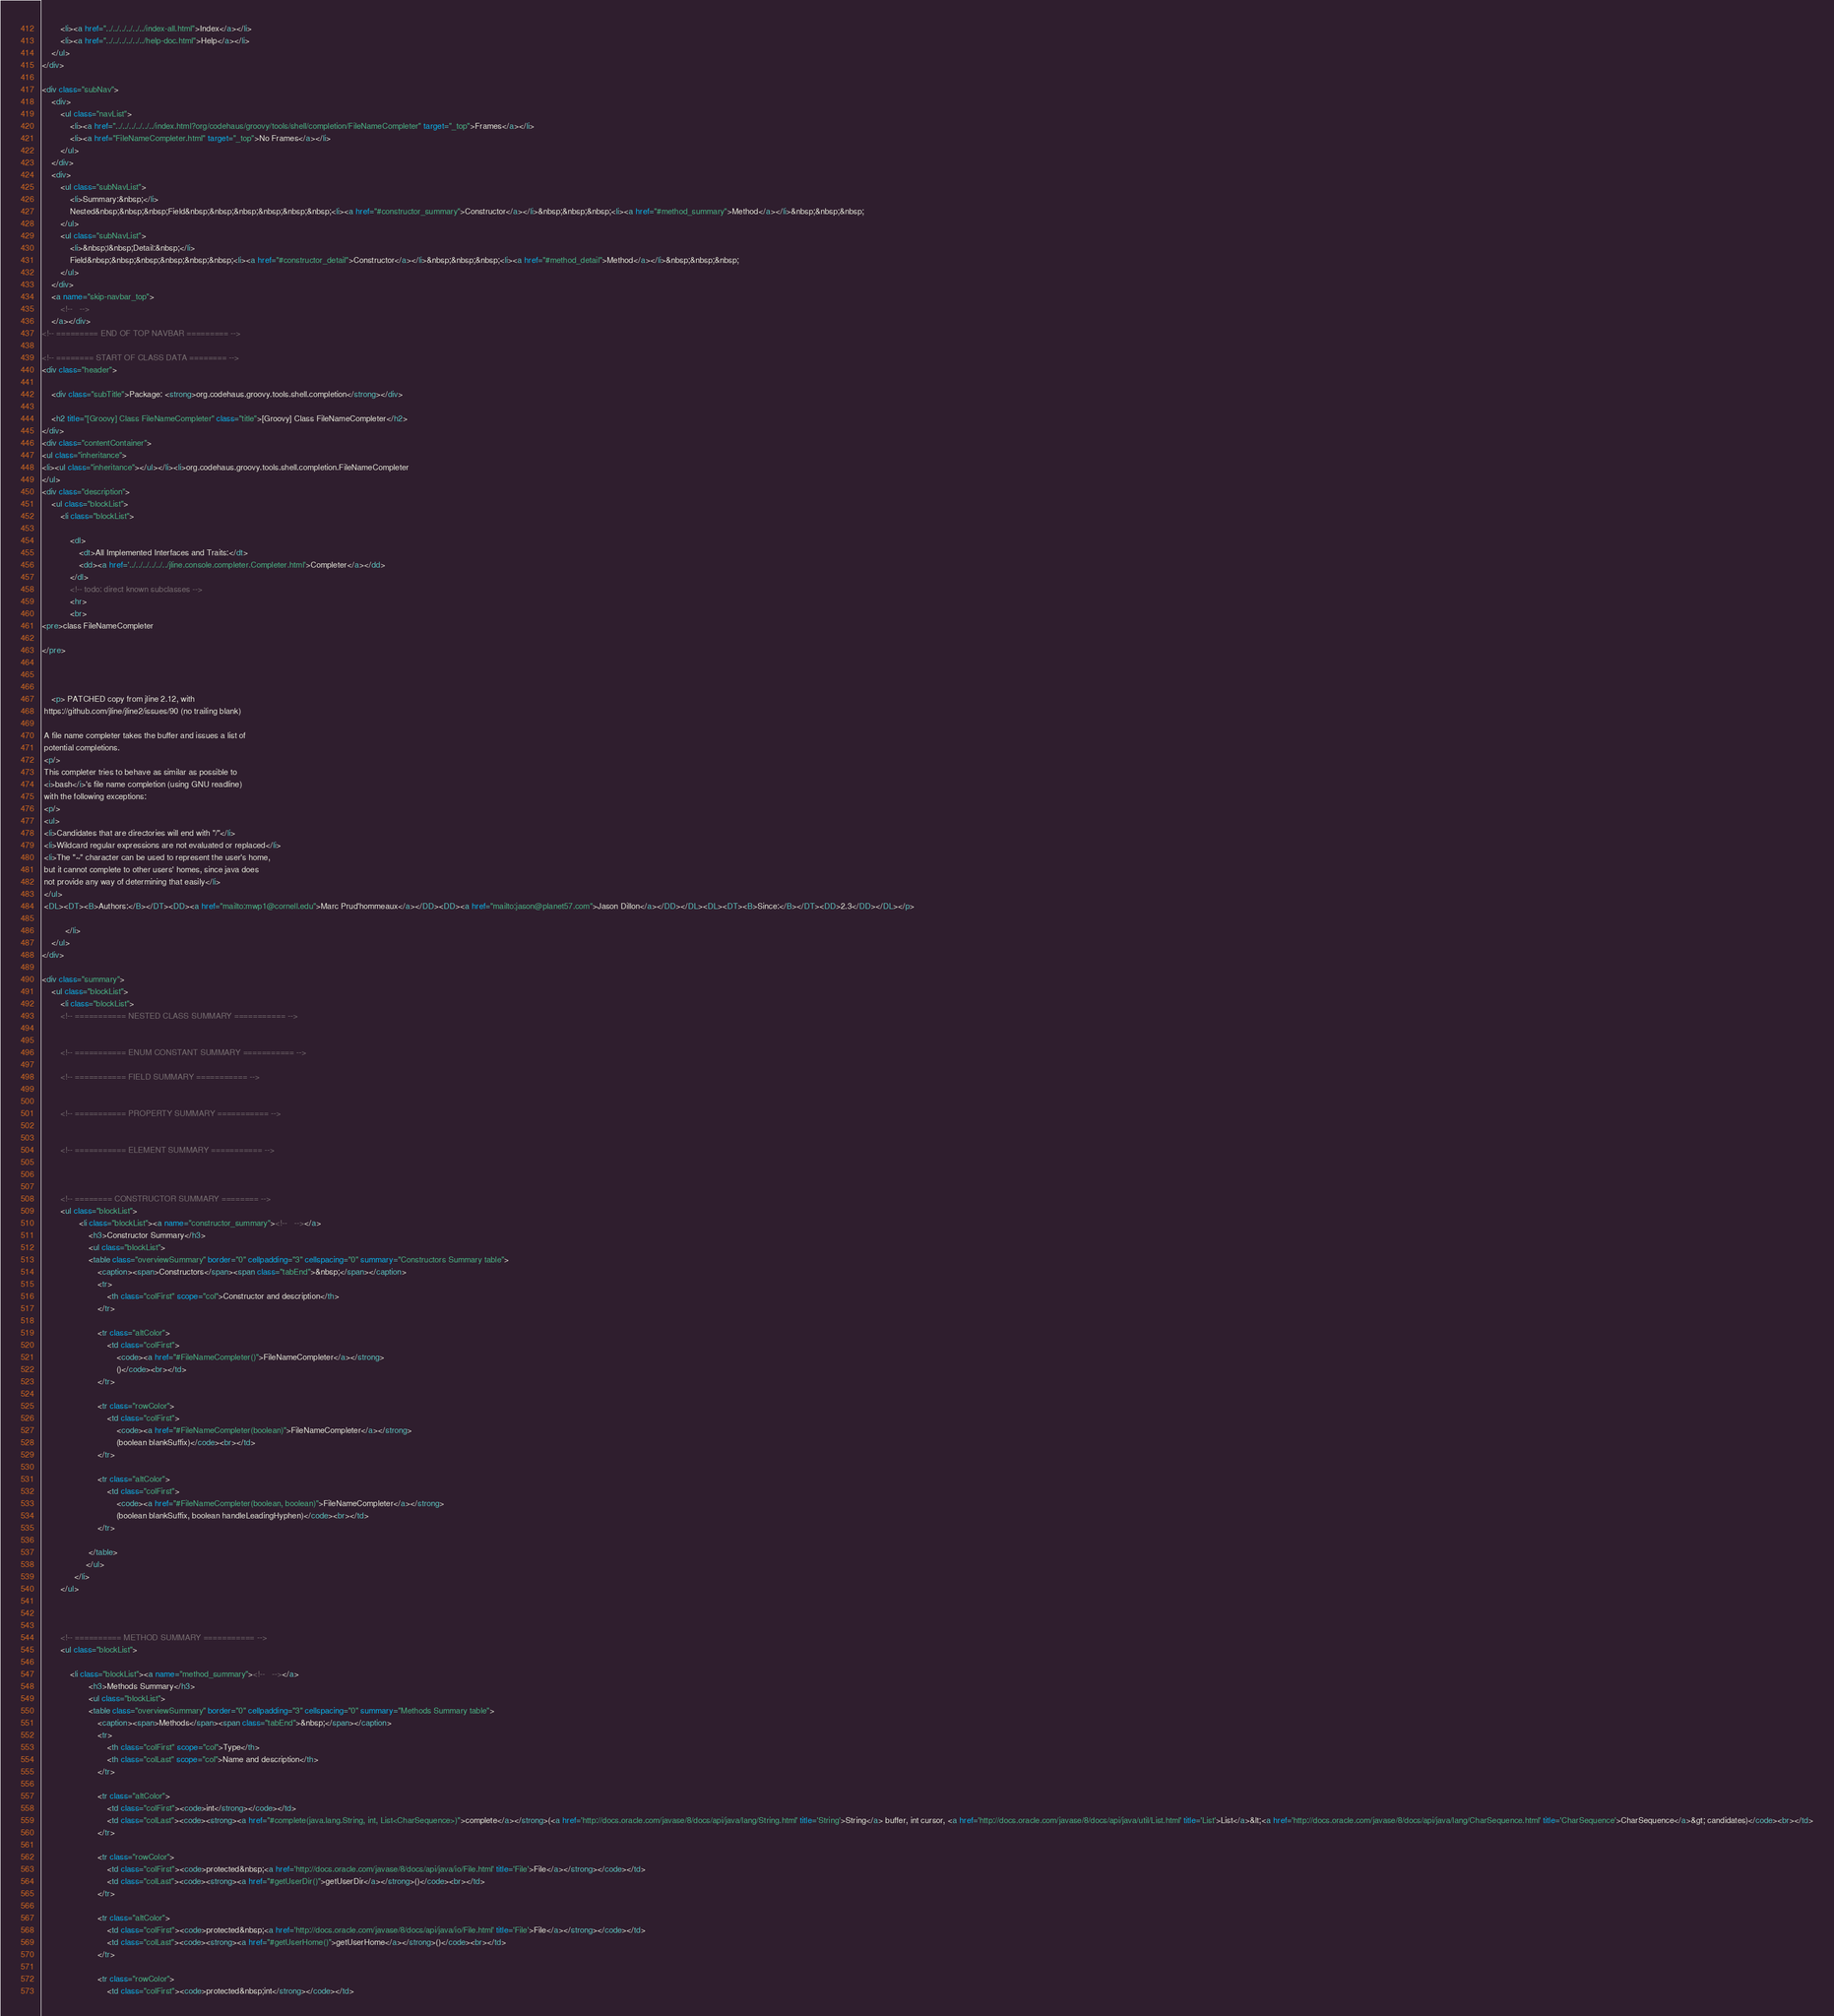Convert code to text. <code><loc_0><loc_0><loc_500><loc_500><_HTML_>        <li><a href="../../../../../../index-all.html">Index</a></li>
        <li><a href="../../../../../../help-doc.html">Help</a></li>
    </ul>
</div>

<div class="subNav">
    <div>
        <ul class="navList">
            <li><a href="../../../../../../index.html?org/codehaus/groovy/tools/shell/completion/FileNameCompleter" target="_top">Frames</a></li>
            <li><a href="FileNameCompleter.html" target="_top">No Frames</a></li>
        </ul>
    </div>
    <div>
        <ul class="subNavList">
            <li>Summary:&nbsp;</li>
            Nested&nbsp;&nbsp;&nbsp;Field&nbsp;&nbsp;&nbsp;&nbsp;&nbsp;&nbsp;<li><a href="#constructor_summary">Constructor</a></li>&nbsp;&nbsp;&nbsp;<li><a href="#method_summary">Method</a></li>&nbsp;&nbsp;&nbsp;
        </ul>
        <ul class="subNavList">
            <li>&nbsp;|&nbsp;Detail:&nbsp;</li>
            Field&nbsp;&nbsp;&nbsp;&nbsp;&nbsp;&nbsp;<li><a href="#constructor_detail">Constructor</a></li>&nbsp;&nbsp;&nbsp;<li><a href="#method_detail">Method</a></li>&nbsp;&nbsp;&nbsp;
        </ul>
    </div>
    <a name="skip-navbar_top">
        <!--   -->
    </a></div>
<!-- ========= END OF TOP NAVBAR ========= -->

<!-- ======== START OF CLASS DATA ======== -->
<div class="header">

    <div class="subTitle">Package: <strong>org.codehaus.groovy.tools.shell.completion</strong></div>

    <h2 title="[Groovy] Class FileNameCompleter" class="title">[Groovy] Class FileNameCompleter</h2>
</div>
<div class="contentContainer">
<ul class="inheritance">
<li><ul class="inheritance"></ul></li><li>org.codehaus.groovy.tools.shell.completion.FileNameCompleter
</ul>
<div class="description">
    <ul class="blockList">
        <li class="blockList">

            <dl>
                <dt>All Implemented Interfaces and Traits:</dt>
                <dd><a href='../../../../../../jline.console.completer.Completer.html'>Completer</a></dd>
            </dl>
            <!-- todo: direct known subclasses -->
            <hr>
            <br>
<pre>class FileNameCompleter

</pre>



    <p> PATCHED copy from jline 2.12, with
 https://github.com/jline/jline2/issues/90 (no trailing blank)

 A file name completer takes the buffer and issues a list of
 potential completions.
 <p/>
 This completer tries to behave as similar as possible to
 <i>bash</i>'s file name completion (using GNU readline)
 with the following exceptions:
 <p/>
 <ul>
 <li>Candidates that are directories will end with "/"</li>
 <li>Wildcard regular expressions are not evaluated or replaced</li>
 <li>The "~" character can be used to represent the user's home,
 but it cannot complete to other users' homes, since java does
 not provide any way of determining that easily</li>
 </ul>
 <DL><DT><B>Authors:</B></DT><DD><a href="mailto:mwp1@cornell.edu">Marc Prud'hommeaux</a></DD><DD><a href="mailto:jason@planet57.com">Jason Dillon</a></DD></DL><DL><DT><B>Since:</B></DT><DD>2.3</DD></DL></p>

          </li>
    </ul>
</div>

<div class="summary">
    <ul class="blockList">
        <li class="blockList">
        <!-- =========== NESTED CLASS SUMMARY =========== -->
        

        <!-- =========== ENUM CONSTANT SUMMARY =========== -->
        
        <!-- =========== FIELD SUMMARY =========== -->
        

        <!-- =========== PROPERTY SUMMARY =========== -->
        

        <!-- =========== ELEMENT SUMMARY =========== -->
        

        
        <!-- ======== CONSTRUCTOR SUMMARY ======== -->
        <ul class="blockList">
                <li class="blockList"><a name="constructor_summary"><!--   --></a>
                    <h3>Constructor Summary</h3>
                    <ul class="blockList">
                    <table class="overviewSummary" border="0" cellpadding="3" cellspacing="0" summary="Constructors Summary table">
                        <caption><span>Constructors</span><span class="tabEnd">&nbsp;</span></caption>
                        <tr>
                            <th class="colFirst" scope="col">Constructor and description</th>
                        </tr>
                        
                        <tr class="altColor">
                            <td class="colFirst">
                                <code><a href="#FileNameCompleter()">FileNameCompleter</a></strong>
                                ()</code><br></td>
                        </tr>
                        
                        <tr class="rowColor">
                            <td class="colFirst">
                                <code><a href="#FileNameCompleter(boolean)">FileNameCompleter</a></strong>
                                (boolean blankSuffix)</code><br></td>
                        </tr>
                        
                        <tr class="altColor">
                            <td class="colFirst">
                                <code><a href="#FileNameCompleter(boolean, boolean)">FileNameCompleter</a></strong>
                                (boolean blankSuffix, boolean handleLeadingHyphen)</code><br></td>
                        </tr>
                        
                    </table>
                   </ul>
              </li>
        </ul>
        

        
        <!-- ========== METHOD SUMMARY =========== -->
        <ul class="blockList">
            
            <li class="blockList"><a name="method_summary"><!--   --></a>
                    <h3>Methods Summary</h3>
                    <ul class="blockList">
                    <table class="overviewSummary" border="0" cellpadding="3" cellspacing="0" summary="Methods Summary table">
                        <caption><span>Methods</span><span class="tabEnd">&nbsp;</span></caption>
                        <tr>
                            <th class="colFirst" scope="col">Type</th>
                            <th class="colLast" scope="col">Name and description</th>
                        </tr>
                        
                        <tr class="altColor">
                            <td class="colFirst"><code>int</strong></code></td>
                            <td class="colLast"><code><strong><a href="#complete(java.lang.String, int, List<CharSequence>)">complete</a></strong>(<a href='http://docs.oracle.com/javase/8/docs/api/java/lang/String.html' title='String'>String</a> buffer, int cursor, <a href='http://docs.oracle.com/javase/8/docs/api/java/util/List.html' title='List'>List</a>&lt;<a href='http://docs.oracle.com/javase/8/docs/api/java/lang/CharSequence.html' title='CharSequence'>CharSequence</a>&gt; candidates)</code><br></td>
                        </tr>
                        
                        <tr class="rowColor">
                            <td class="colFirst"><code>protected&nbsp;<a href='http://docs.oracle.com/javase/8/docs/api/java/io/File.html' title='File'>File</a></strong></code></td>
                            <td class="colLast"><code><strong><a href="#getUserDir()">getUserDir</a></strong>()</code><br></td>
                        </tr>
                        
                        <tr class="altColor">
                            <td class="colFirst"><code>protected&nbsp;<a href='http://docs.oracle.com/javase/8/docs/api/java/io/File.html' title='File'>File</a></strong></code></td>
                            <td class="colLast"><code><strong><a href="#getUserHome()">getUserHome</a></strong>()</code><br></td>
                        </tr>
                        
                        <tr class="rowColor">
                            <td class="colFirst"><code>protected&nbsp;int</strong></code></td></code> 